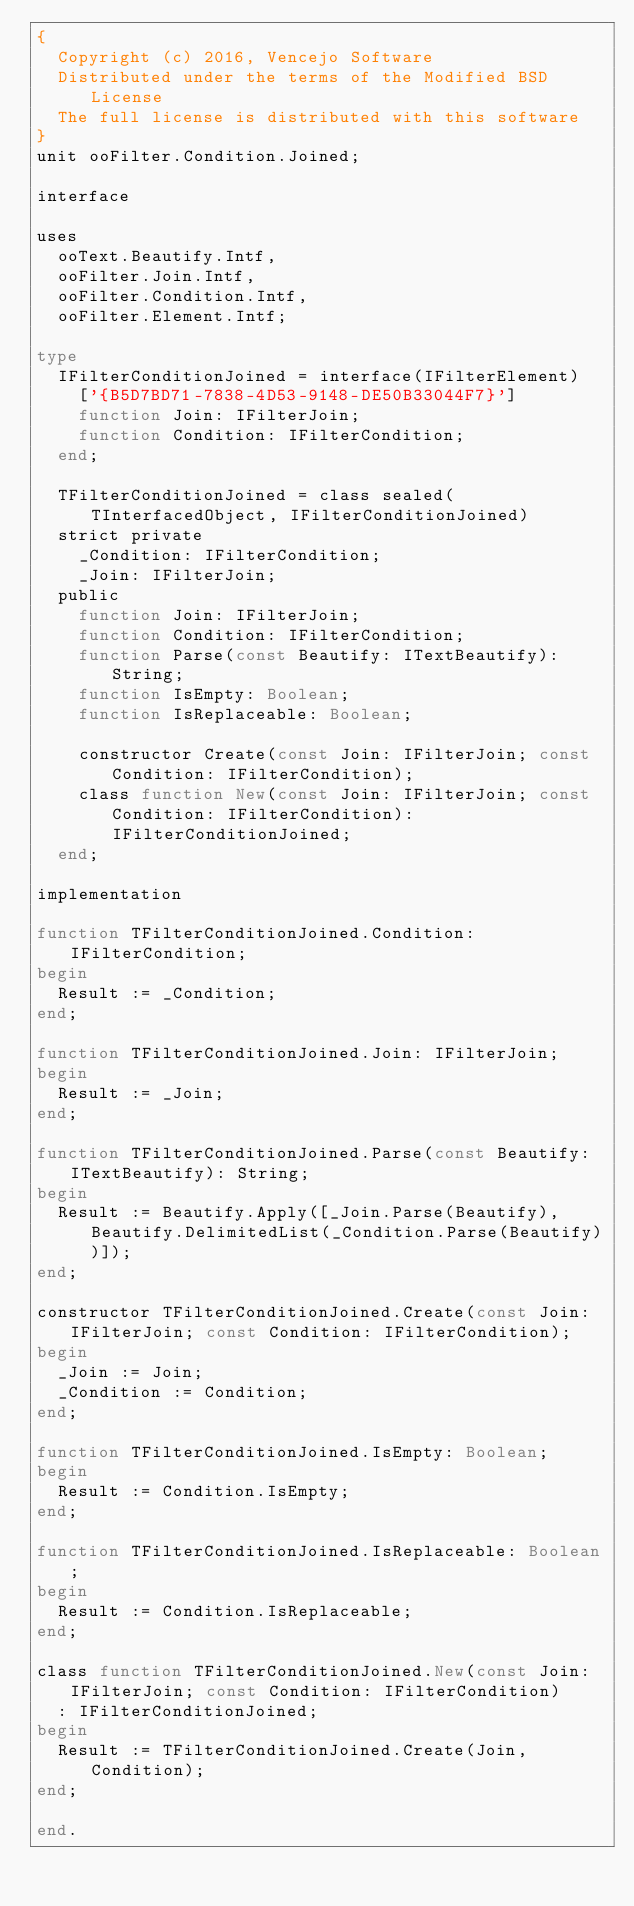<code> <loc_0><loc_0><loc_500><loc_500><_Pascal_>{
  Copyright (c) 2016, Vencejo Software
  Distributed under the terms of the Modified BSD License
  The full license is distributed with this software
}
unit ooFilter.Condition.Joined;

interface

uses
  ooText.Beautify.Intf,
  ooFilter.Join.Intf,
  ooFilter.Condition.Intf,
  ooFilter.Element.Intf;

type
  IFilterConditionJoined = interface(IFilterElement)
    ['{B5D7BD71-7838-4D53-9148-DE50B33044F7}']
    function Join: IFilterJoin;
    function Condition: IFilterCondition;
  end;

  TFilterConditionJoined = class sealed(TInterfacedObject, IFilterConditionJoined)
  strict private
    _Condition: IFilterCondition;
    _Join: IFilterJoin;
  public
    function Join: IFilterJoin;
    function Condition: IFilterCondition;
    function Parse(const Beautify: ITextBeautify): String;
    function IsEmpty: Boolean;
    function IsReplaceable: Boolean;

    constructor Create(const Join: IFilterJoin; const Condition: IFilterCondition);
    class function New(const Join: IFilterJoin; const Condition: IFilterCondition): IFilterConditionJoined;
  end;

implementation

function TFilterConditionJoined.Condition: IFilterCondition;
begin
  Result := _Condition;
end;

function TFilterConditionJoined.Join: IFilterJoin;
begin
  Result := _Join;
end;

function TFilterConditionJoined.Parse(const Beautify: ITextBeautify): String;
begin
  Result := Beautify.Apply([_Join.Parse(Beautify), Beautify.DelimitedList(_Condition.Parse(Beautify))]);
end;

constructor TFilterConditionJoined.Create(const Join: IFilterJoin; const Condition: IFilterCondition);
begin
  _Join := Join;
  _Condition := Condition;
end;

function TFilterConditionJoined.IsEmpty: Boolean;
begin
  Result := Condition.IsEmpty;
end;

function TFilterConditionJoined.IsReplaceable: Boolean;
begin
  Result := Condition.IsReplaceable;
end;

class function TFilterConditionJoined.New(const Join: IFilterJoin; const Condition: IFilterCondition)
  : IFilterConditionJoined;
begin
  Result := TFilterConditionJoined.Create(Join, Condition);
end;

end.
</code> 